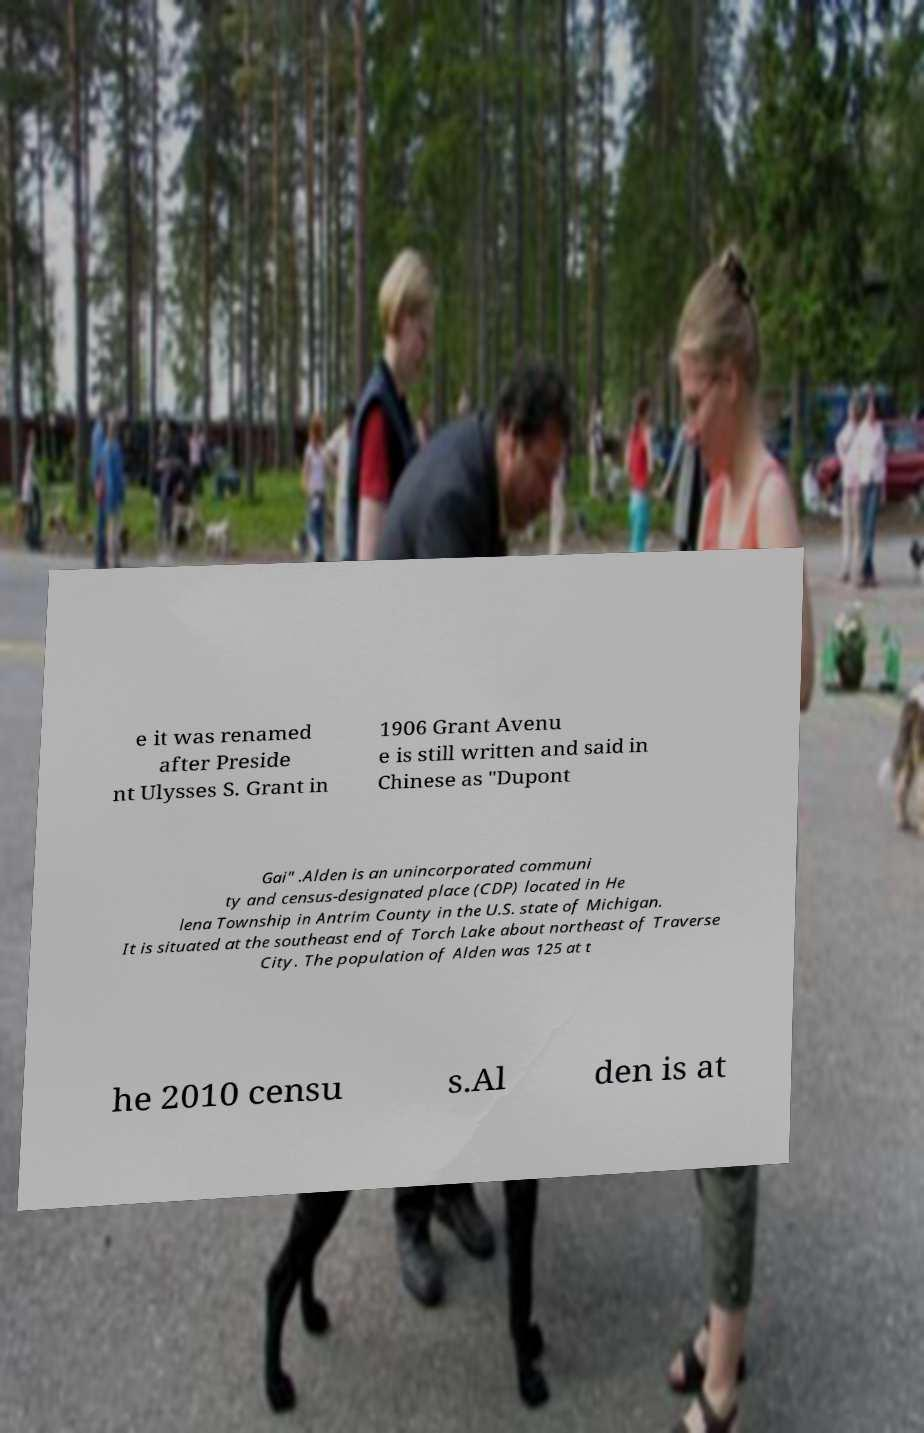Can you accurately transcribe the text from the provided image for me? e it was renamed after Preside nt Ulysses S. Grant in 1906 Grant Avenu e is still written and said in Chinese as "Dupont Gai" .Alden is an unincorporated communi ty and census-designated place (CDP) located in He lena Township in Antrim County in the U.S. state of Michigan. It is situated at the southeast end of Torch Lake about northeast of Traverse City. The population of Alden was 125 at t he 2010 censu s.Al den is at 